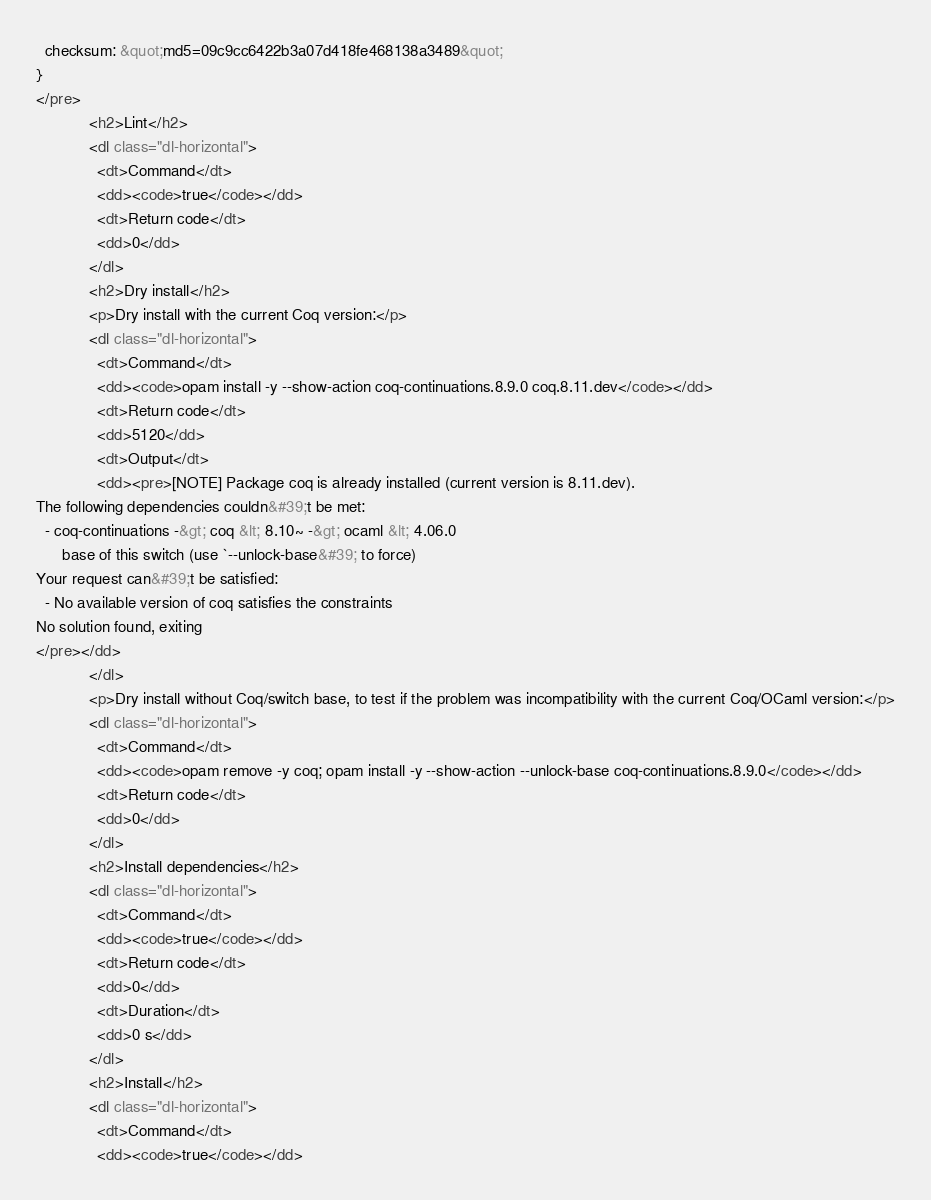<code> <loc_0><loc_0><loc_500><loc_500><_HTML_>  checksum: &quot;md5=09c9cc6422b3a07d418fe468138a3489&quot;
}
</pre>
            <h2>Lint</h2>
            <dl class="dl-horizontal">
              <dt>Command</dt>
              <dd><code>true</code></dd>
              <dt>Return code</dt>
              <dd>0</dd>
            </dl>
            <h2>Dry install</h2>
            <p>Dry install with the current Coq version:</p>
            <dl class="dl-horizontal">
              <dt>Command</dt>
              <dd><code>opam install -y --show-action coq-continuations.8.9.0 coq.8.11.dev</code></dd>
              <dt>Return code</dt>
              <dd>5120</dd>
              <dt>Output</dt>
              <dd><pre>[NOTE] Package coq is already installed (current version is 8.11.dev).
The following dependencies couldn&#39;t be met:
  - coq-continuations -&gt; coq &lt; 8.10~ -&gt; ocaml &lt; 4.06.0
      base of this switch (use `--unlock-base&#39; to force)
Your request can&#39;t be satisfied:
  - No available version of coq satisfies the constraints
No solution found, exiting
</pre></dd>
            </dl>
            <p>Dry install without Coq/switch base, to test if the problem was incompatibility with the current Coq/OCaml version:</p>
            <dl class="dl-horizontal">
              <dt>Command</dt>
              <dd><code>opam remove -y coq; opam install -y --show-action --unlock-base coq-continuations.8.9.0</code></dd>
              <dt>Return code</dt>
              <dd>0</dd>
            </dl>
            <h2>Install dependencies</h2>
            <dl class="dl-horizontal">
              <dt>Command</dt>
              <dd><code>true</code></dd>
              <dt>Return code</dt>
              <dd>0</dd>
              <dt>Duration</dt>
              <dd>0 s</dd>
            </dl>
            <h2>Install</h2>
            <dl class="dl-horizontal">
              <dt>Command</dt>
              <dd><code>true</code></dd></code> 